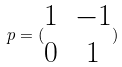<formula> <loc_0><loc_0><loc_500><loc_500>p = ( \begin{matrix} 1 & - 1 \\ 0 & 1 \end{matrix} )</formula> 